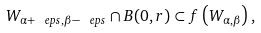Convert formula to latex. <formula><loc_0><loc_0><loc_500><loc_500>W _ { \alpha + \ e p s , \beta - \ e p s } \cap B ( 0 , r ) \subset f \left ( W _ { \alpha , \beta } \right ) ,</formula> 